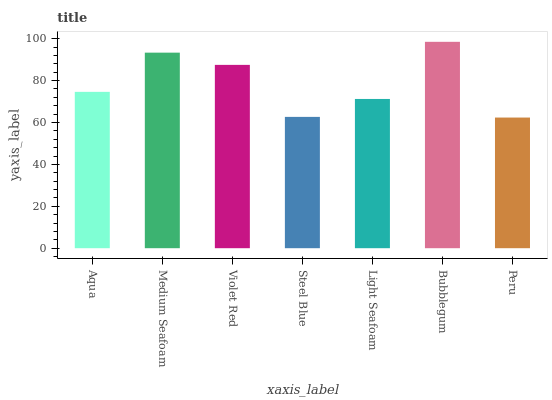Is Peru the minimum?
Answer yes or no. Yes. Is Bubblegum the maximum?
Answer yes or no. Yes. Is Medium Seafoam the minimum?
Answer yes or no. No. Is Medium Seafoam the maximum?
Answer yes or no. No. Is Medium Seafoam greater than Aqua?
Answer yes or no. Yes. Is Aqua less than Medium Seafoam?
Answer yes or no. Yes. Is Aqua greater than Medium Seafoam?
Answer yes or no. No. Is Medium Seafoam less than Aqua?
Answer yes or no. No. Is Aqua the high median?
Answer yes or no. Yes. Is Aqua the low median?
Answer yes or no. Yes. Is Steel Blue the high median?
Answer yes or no. No. Is Steel Blue the low median?
Answer yes or no. No. 